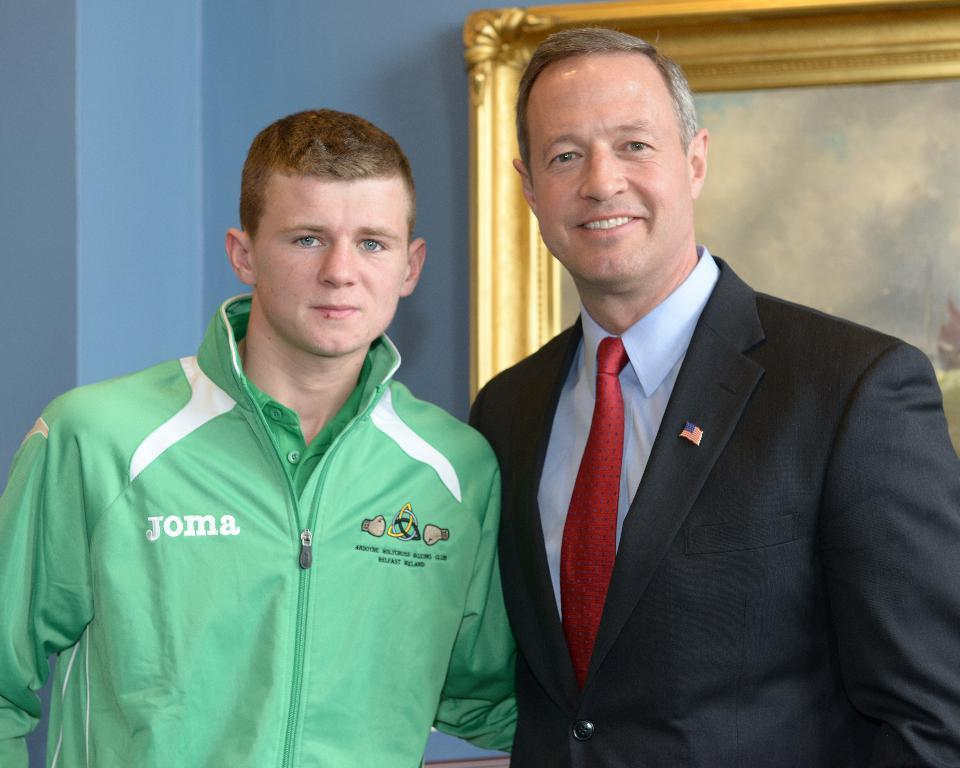<image>
Present a compact description of the photo's key features. Two men are looking at the camera, and one of them is wearing a Joma jacket. 